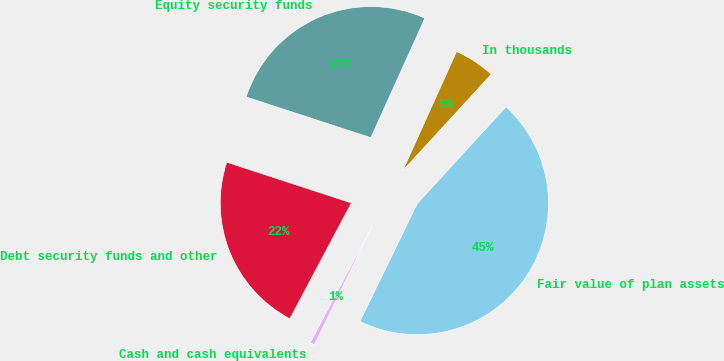<chart> <loc_0><loc_0><loc_500><loc_500><pie_chart><fcel>In thousands<fcel>Equity security funds<fcel>Debt security funds and other<fcel>Cash and cash equivalents<fcel>Fair value of plan assets<nl><fcel>5.06%<fcel>26.73%<fcel>22.25%<fcel>0.57%<fcel>45.39%<nl></chart> 